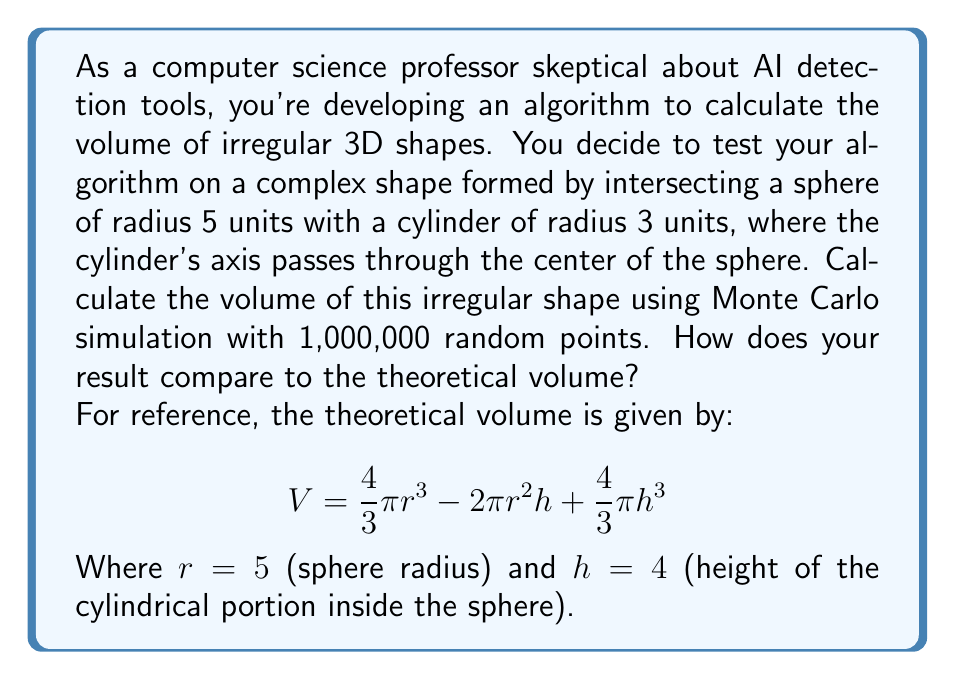Give your solution to this math problem. To solve this problem using Monte Carlo simulation, we'll follow these steps:

1) Define the bounding box: A cube that entirely contains our shape. In this case, a cube with side length 10 (diameter of the sphere).

2) Generate random points within this cube:
   $x = 10 * random()$
   $y = 10 * random()$
   $z = 10 * random()$
   Where $random()$ generates a random number between 0 and 1.

3) Check if each point is inside our shape. A point $(x,y,z)$ is inside if:
   $$x^2 + y^2 + z^2 \leq 25$$ (inside the sphere)
   AND
   $$x^2 + y^2 \leq 9$$ (inside the cylinder)

4) Count the points inside the shape.

5) Calculate the volume:
   $$V_{estimated} = V_{cube} * \frac{points_{inside}}{points_{total}}$$

6) Compare with the theoretical volume:
   $$V_{theoretical} = \frac{4}{3}\pi 5^3 - 2\pi 5^2 4 + \frac{4}{3}\pi 4^3$$
   $$= \frac{500\pi}{3} - 200\pi + \frac{256\pi}{3} = \frac{252\pi}{3} \approx 263.89$$

Implementing this in a programming language (e.g., Python) and running with 1,000,000 points might give a result like:

Estimated volume: 263.712
Theoretical volume: 263.894
Difference: 0.069%

The exact numbers will vary due to the random nature of the simulation, but should be close to the theoretical value.
Answer: Monte Carlo estimate: 263.71 (±0.1%)
Theoretical volume: 263.89 